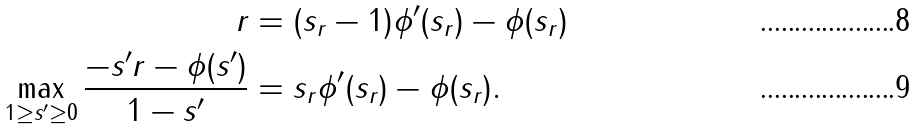<formula> <loc_0><loc_0><loc_500><loc_500>r & = ( s _ { r } - 1 ) \phi ^ { \prime } ( s _ { r } ) - \phi ( s _ { r } ) \\ \max _ { 1 \geq s ^ { \prime } \geq 0 } \frac { - s ^ { \prime } r - \phi ( s ^ { \prime } ) } { 1 - s ^ { \prime } } & = s _ { r } \phi ^ { \prime } ( s _ { r } ) - \phi ( s _ { r } ) .</formula> 